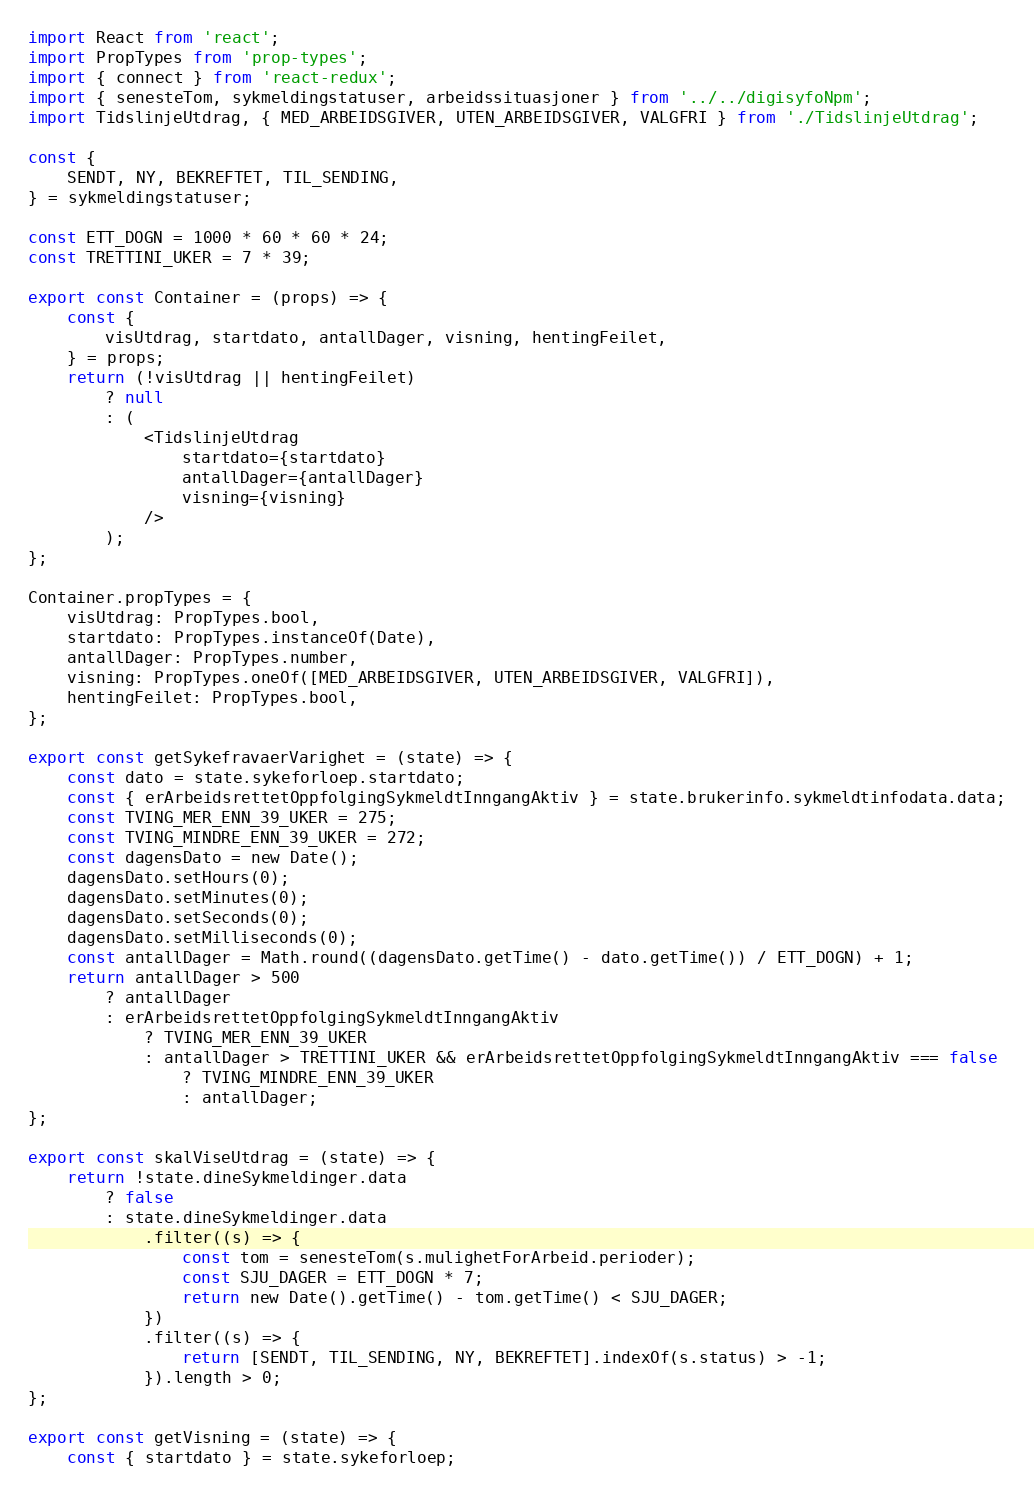<code> <loc_0><loc_0><loc_500><loc_500><_JavaScript_>import React from 'react';
import PropTypes from 'prop-types';
import { connect } from 'react-redux';
import { senesteTom, sykmeldingstatuser, arbeidssituasjoner } from '../../digisyfoNpm';
import TidslinjeUtdrag, { MED_ARBEIDSGIVER, UTEN_ARBEIDSGIVER, VALGFRI } from './TidslinjeUtdrag';

const {
    SENDT, NY, BEKREFTET, TIL_SENDING,
} = sykmeldingstatuser;

const ETT_DOGN = 1000 * 60 * 60 * 24;
const TRETTINI_UKER = 7 * 39;

export const Container = (props) => {
    const {
        visUtdrag, startdato, antallDager, visning, hentingFeilet,
    } = props;
    return (!visUtdrag || hentingFeilet)
        ? null
        : (
            <TidslinjeUtdrag
                startdato={startdato}
                antallDager={antallDager}
                visning={visning}
            />
        );
};

Container.propTypes = {
    visUtdrag: PropTypes.bool,
    startdato: PropTypes.instanceOf(Date),
    antallDager: PropTypes.number,
    visning: PropTypes.oneOf([MED_ARBEIDSGIVER, UTEN_ARBEIDSGIVER, VALGFRI]),
    hentingFeilet: PropTypes.bool,
};

export const getSykefravaerVarighet = (state) => {
    const dato = state.sykeforloep.startdato;
    const { erArbeidsrettetOppfolgingSykmeldtInngangAktiv } = state.brukerinfo.sykmeldtinfodata.data;
    const TVING_MER_ENN_39_UKER = 275;
    const TVING_MINDRE_ENN_39_UKER = 272;
    const dagensDato = new Date();
    dagensDato.setHours(0);
    dagensDato.setMinutes(0);
    dagensDato.setSeconds(0);
    dagensDato.setMilliseconds(0);
    const antallDager = Math.round((dagensDato.getTime() - dato.getTime()) / ETT_DOGN) + 1;
    return antallDager > 500
        ? antallDager
        : erArbeidsrettetOppfolgingSykmeldtInngangAktiv
            ? TVING_MER_ENN_39_UKER
            : antallDager > TRETTINI_UKER && erArbeidsrettetOppfolgingSykmeldtInngangAktiv === false
                ? TVING_MINDRE_ENN_39_UKER
                : antallDager;
};

export const skalViseUtdrag = (state) => {
    return !state.dineSykmeldinger.data
        ? false
        : state.dineSykmeldinger.data
            .filter((s) => {
                const tom = senesteTom(s.mulighetForArbeid.perioder);
                const SJU_DAGER = ETT_DOGN * 7;
                return new Date().getTime() - tom.getTime() < SJU_DAGER;
            })
            .filter((s) => {
                return [SENDT, TIL_SENDING, NY, BEKREFTET].indexOf(s.status) > -1;
            }).length > 0;
};

export const getVisning = (state) => {
    const { startdato } = state.sykeforloep;</code> 